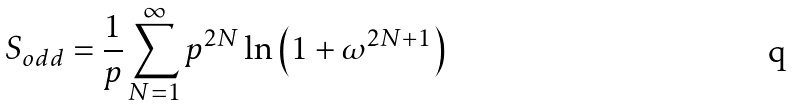<formula> <loc_0><loc_0><loc_500><loc_500>S _ { o d d } = \frac { 1 } { p } \sum _ { N = 1 } ^ { \infty } p ^ { 2 N } \ln \left ( 1 + \omega ^ { 2 N + 1 } \right )</formula> 